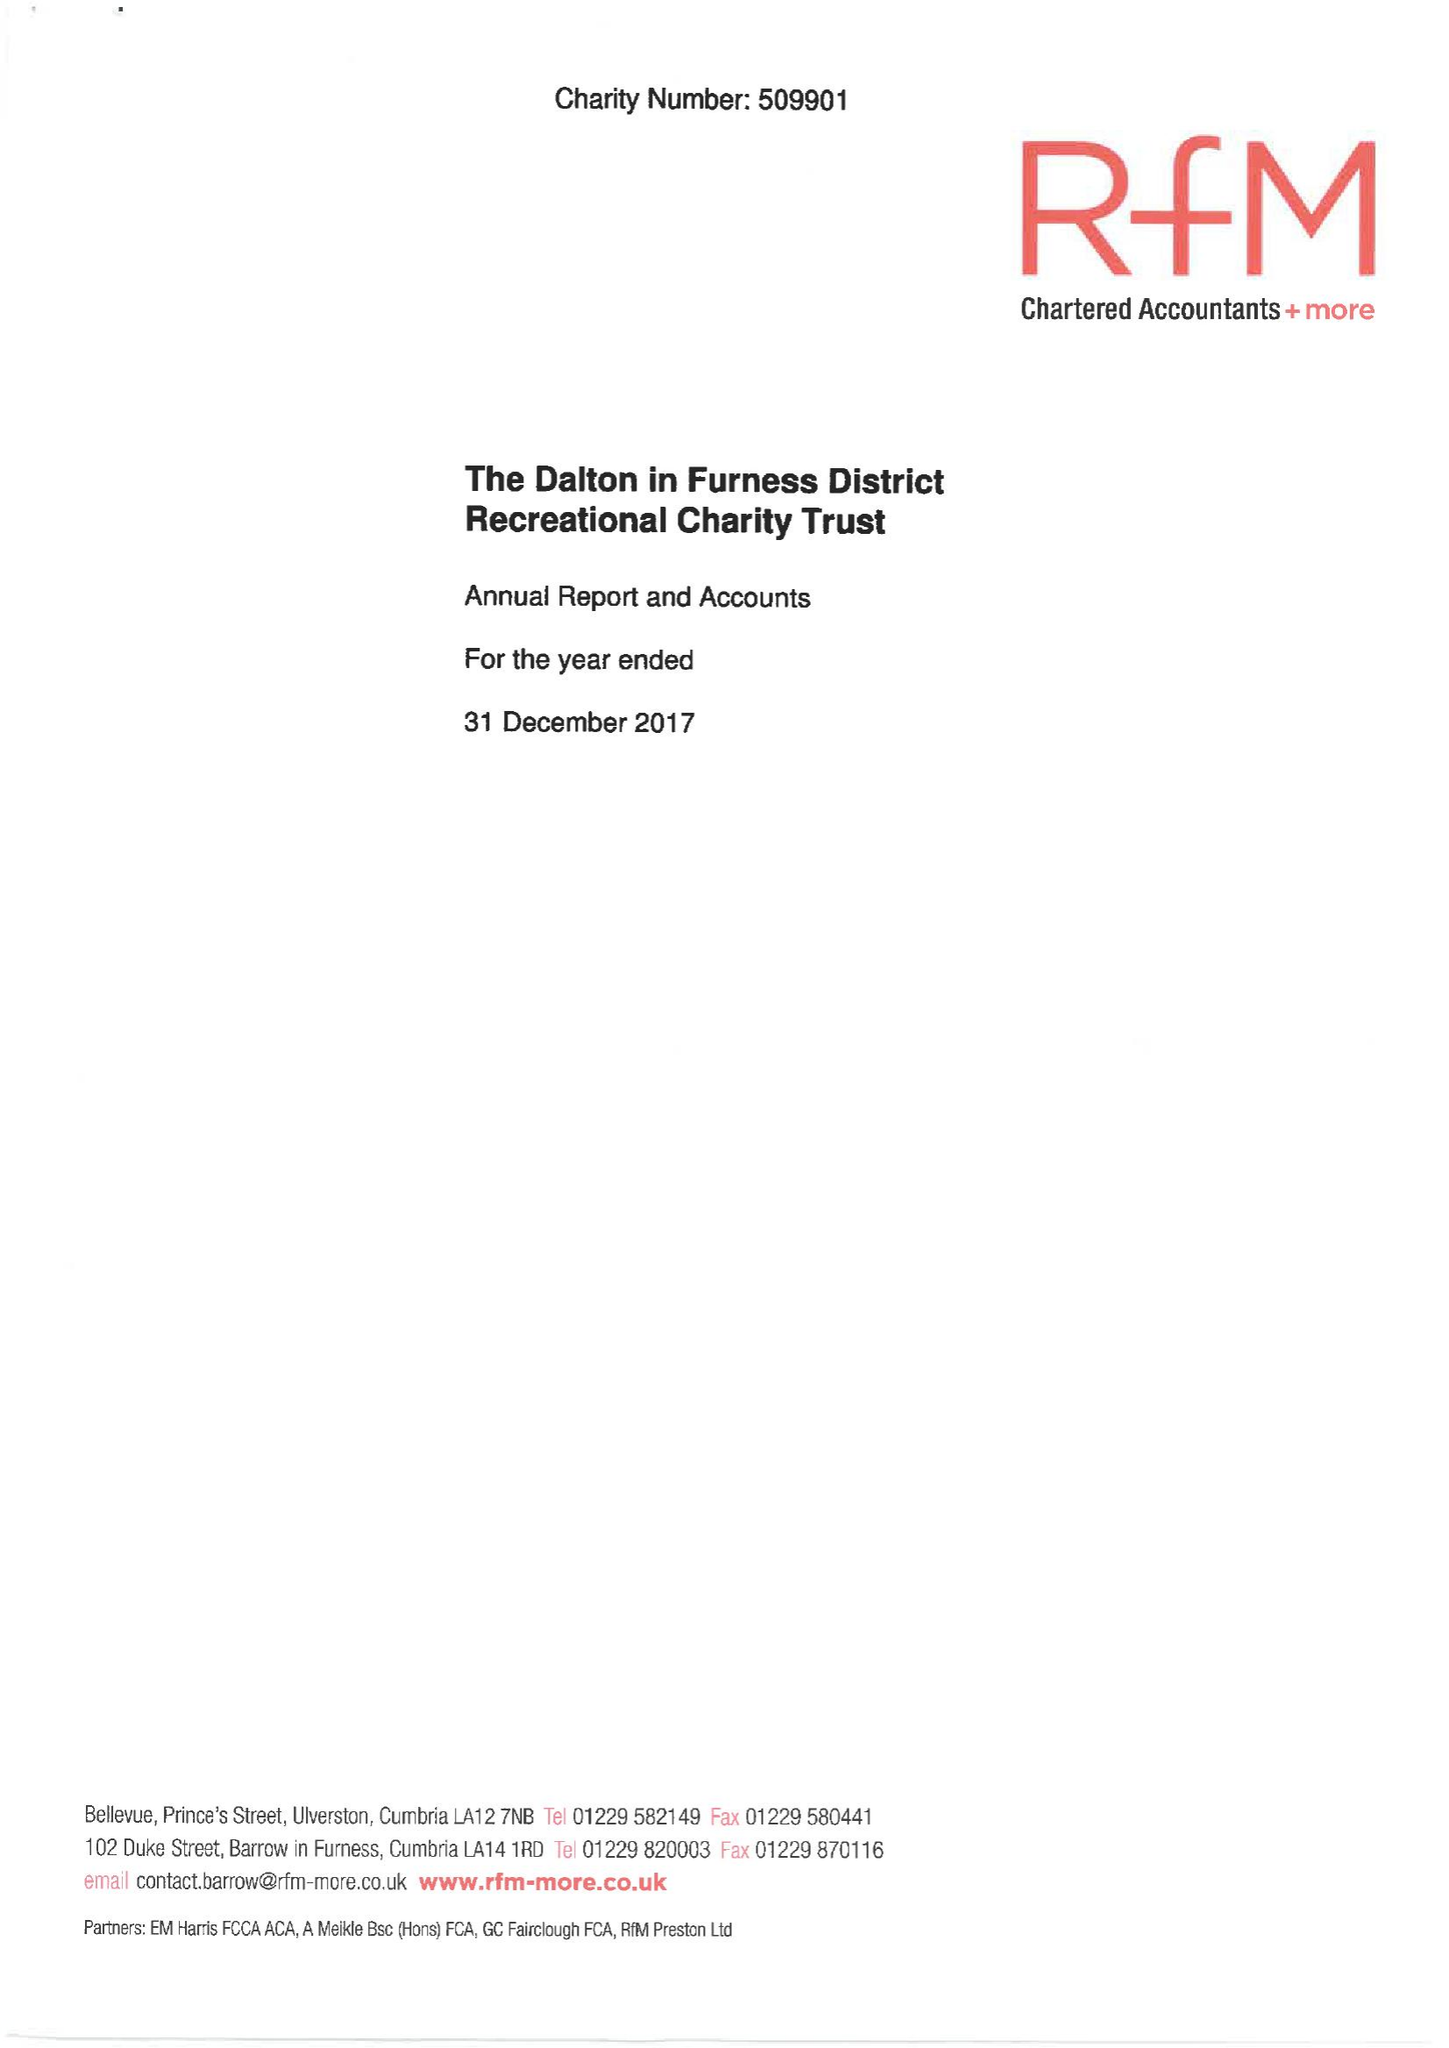What is the value for the charity_number?
Answer the question using a single word or phrase. 509901 